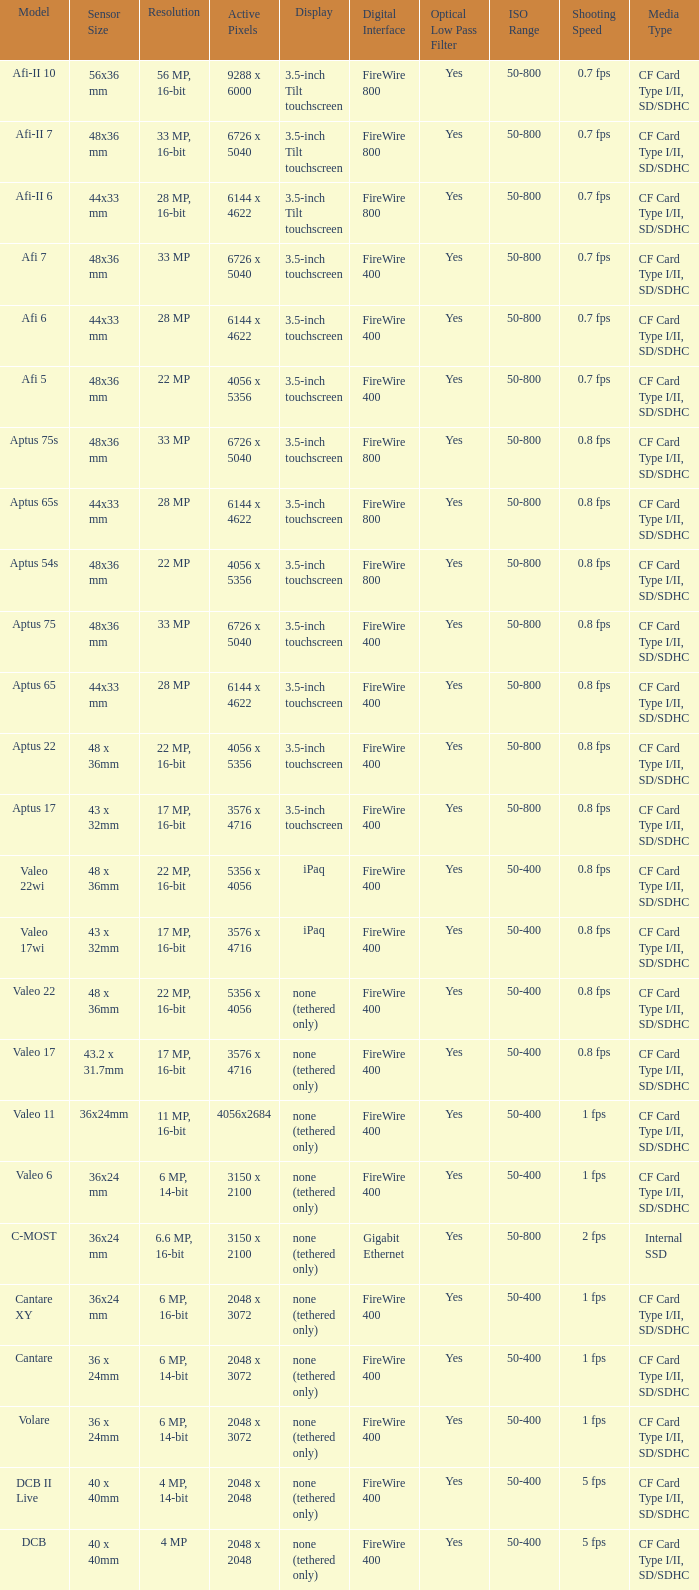What are the active pixels of the cantare model? 2048 x 3072. 